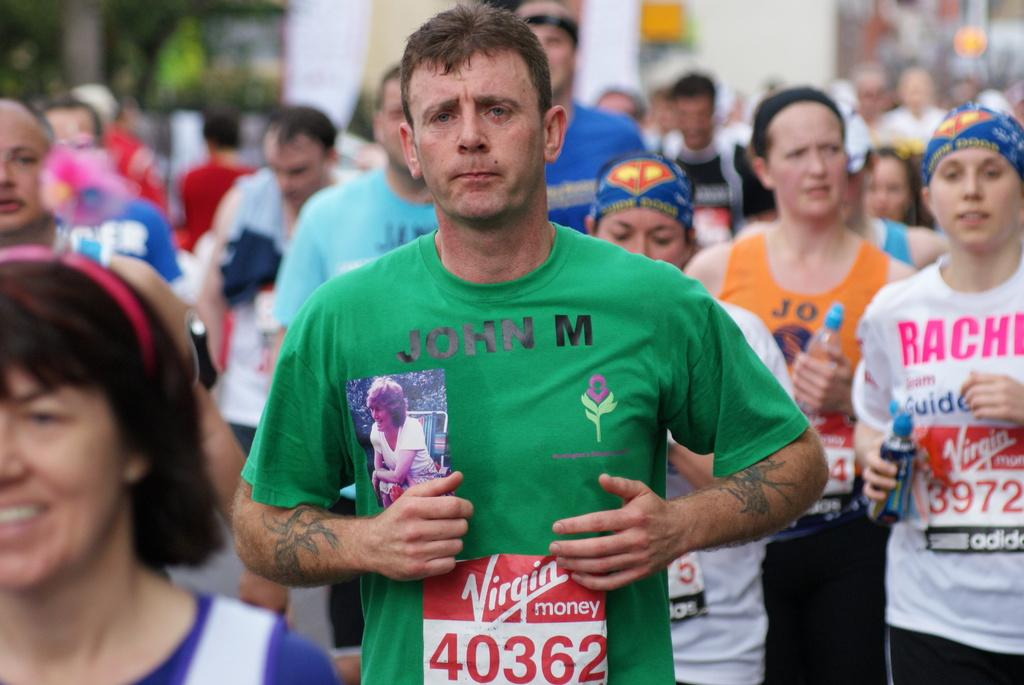What are the people in the image doing? There are many people jogging in the image. How would you describe the background of the image? The background of the image is blurred. What can be seen in the distance in the image? There are buildings and trees in the background of the image. What type of discussion is taking place between the people in the image? There is no discussion taking place in the image; the people are jogging. Can you see any visible arms of the people in the image? The image does not focus on the specific body parts of the people, so it is not possible to determine if their arms are visible. 